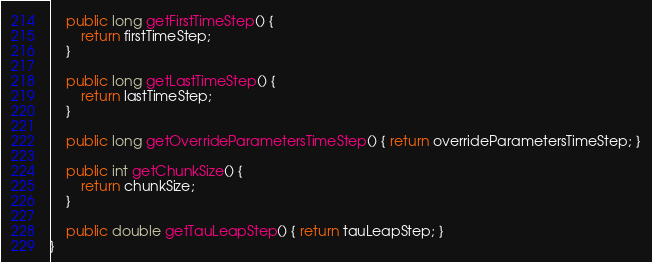Convert code to text. <code><loc_0><loc_0><loc_500><loc_500><_Java_>
    public long getFirstTimeStep() {
        return firstTimeStep;
    }

    public long getLastTimeStep() {
        return lastTimeStep;
    }

    public long getOverrideParametersTimeStep() { return overrideParametersTimeStep; }

    public int getChunkSize() {
        return chunkSize;
    }

    public double getTauLeapStep() { return tauLeapStep; }
}
</code> 